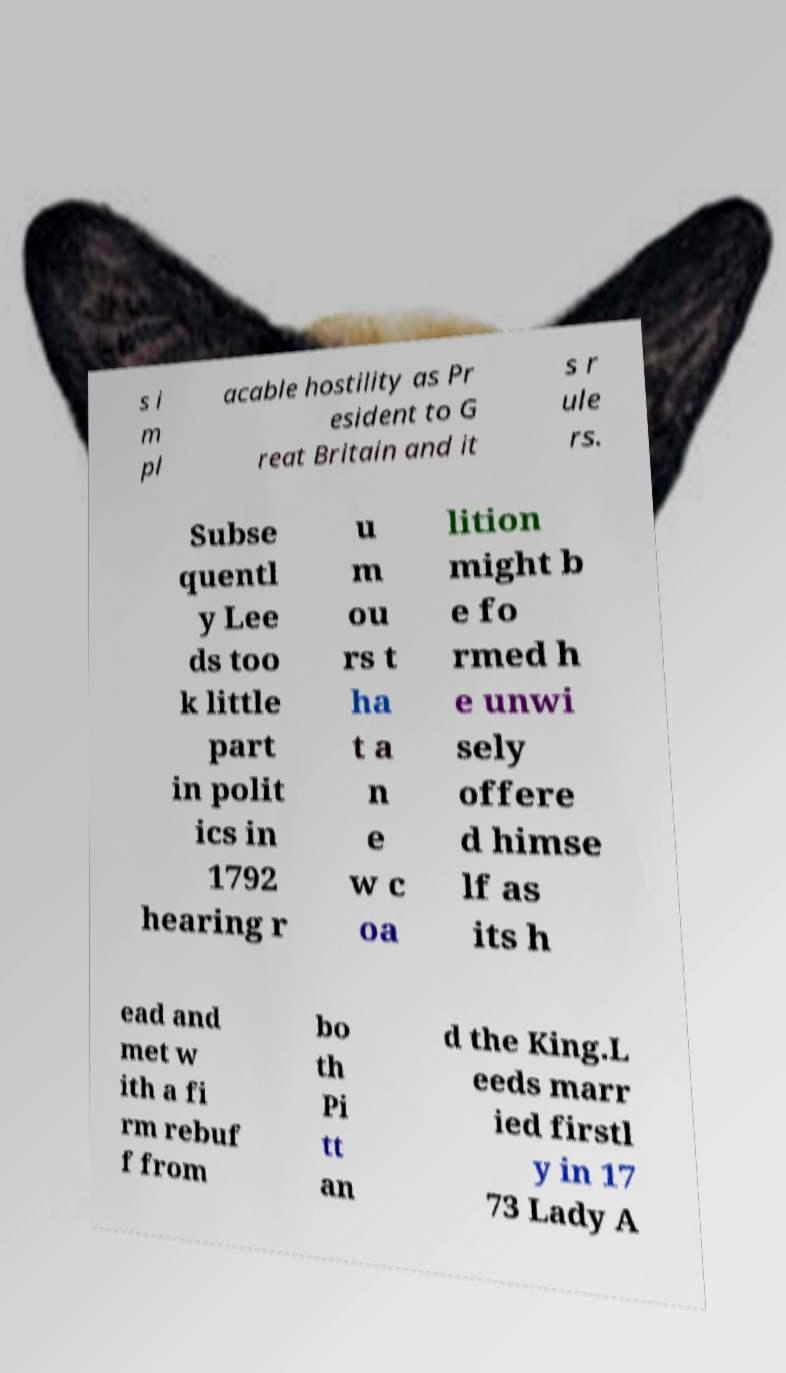What messages or text are displayed in this image? I need them in a readable, typed format. s i m pl acable hostility as Pr esident to G reat Britain and it s r ule rs. Subse quentl y Lee ds too k little part in polit ics in 1792 hearing r u m ou rs t ha t a n e w c oa lition might b e fo rmed h e unwi sely offere d himse lf as its h ead and met w ith a fi rm rebuf f from bo th Pi tt an d the King.L eeds marr ied firstl y in 17 73 Lady A 